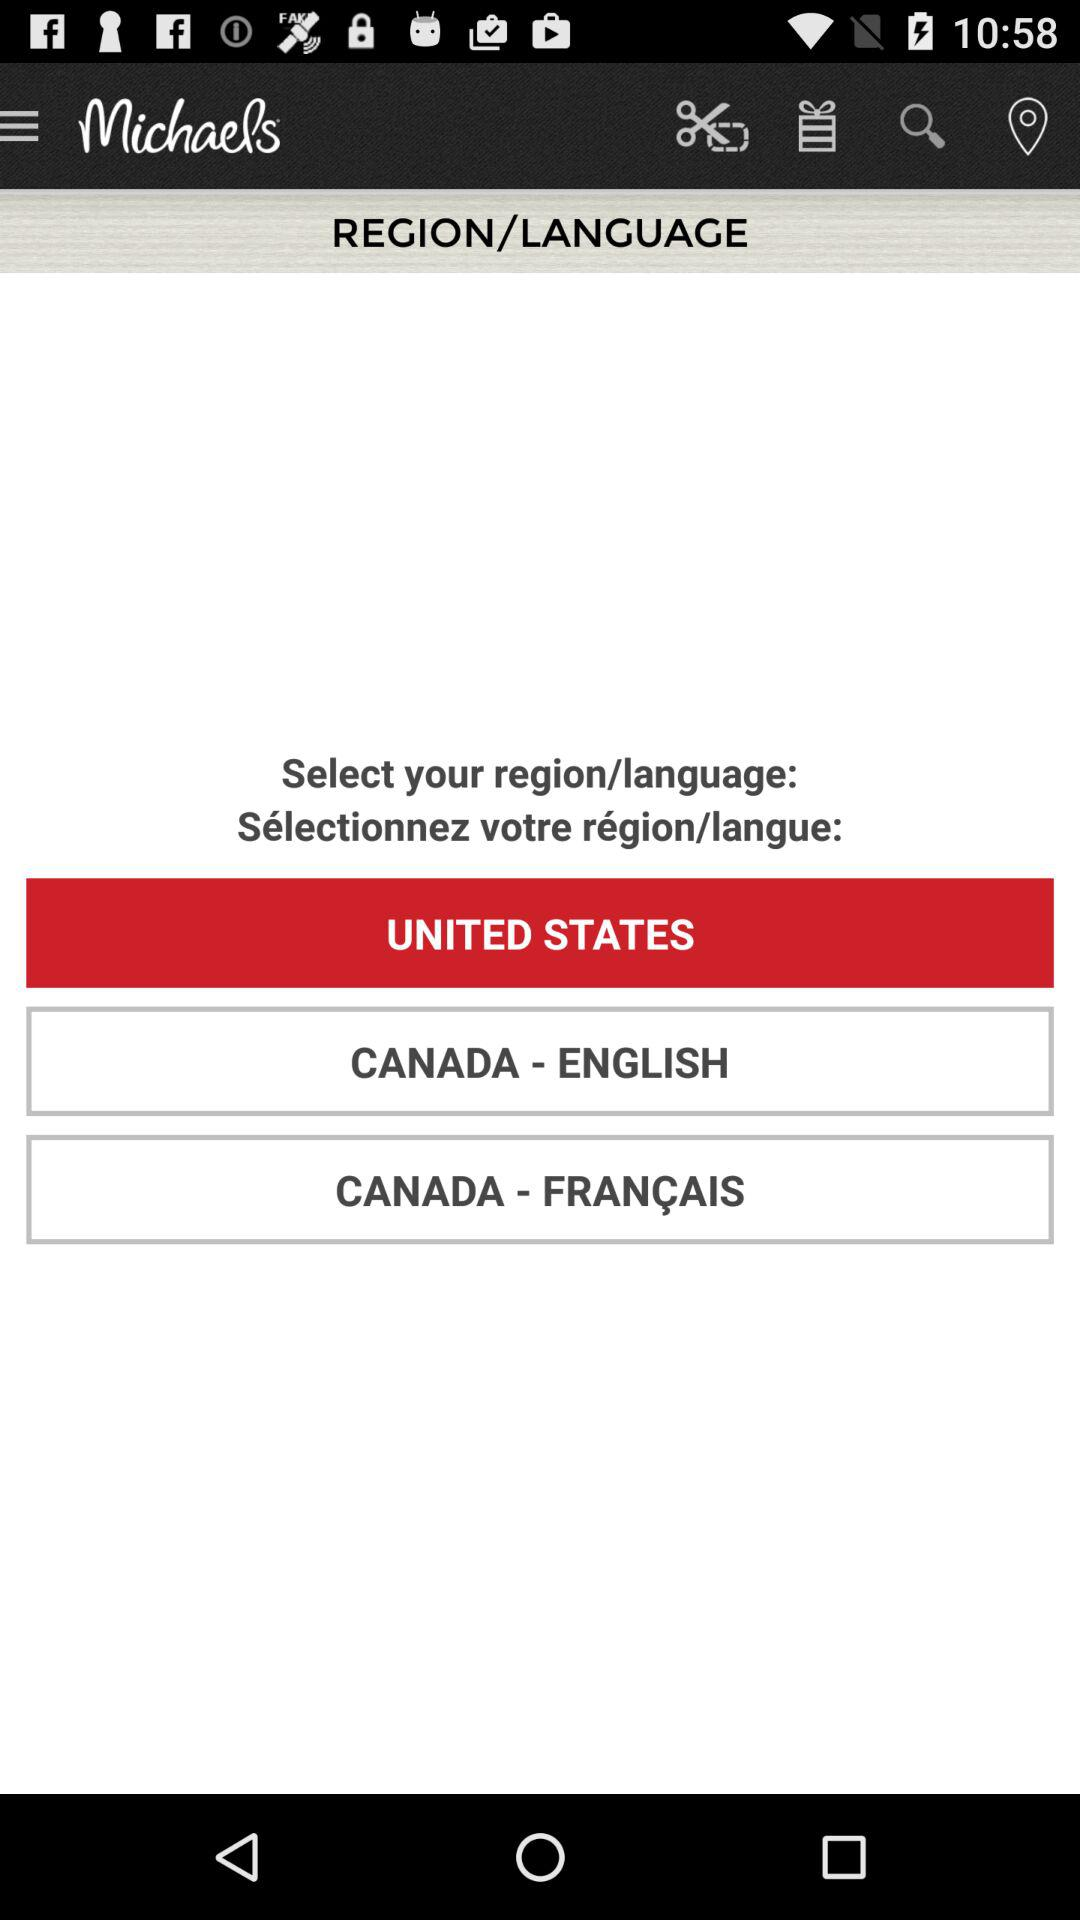What is the selected region? The selected region is the United States. 